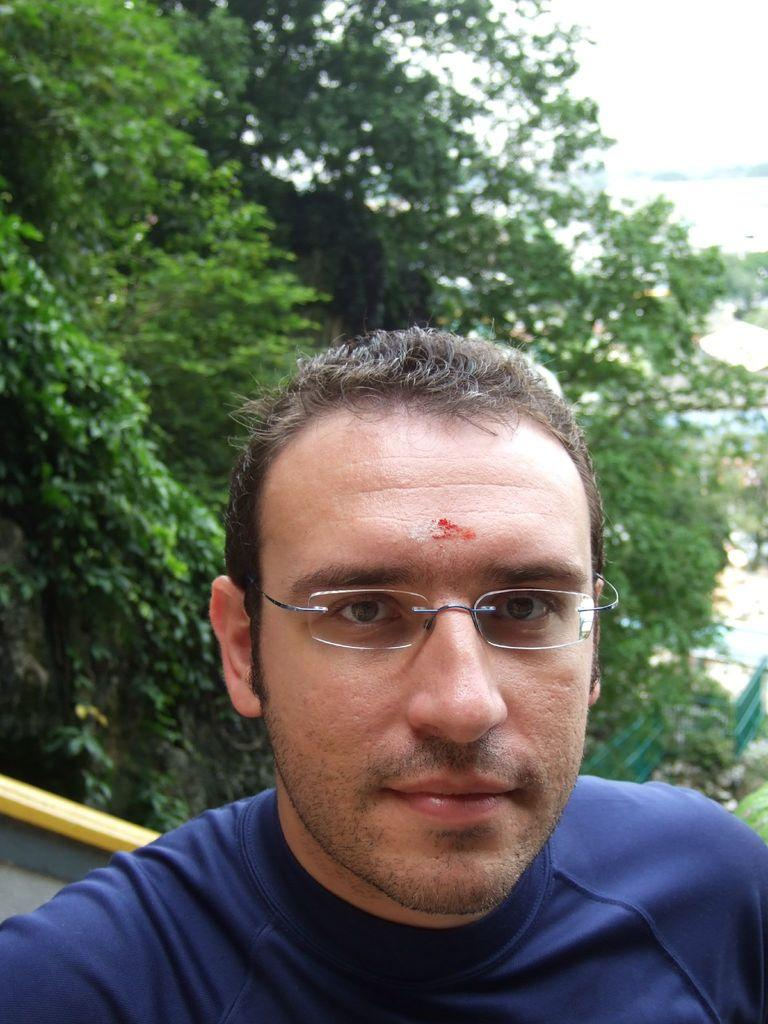Who is the main subject in the image? There is a man in the center of the image. What is the man wearing in the image? The man is wearing glasses. What can be seen in the background of the image? There are trees in the background of the image. What type of lace can be seen on the man's socks in the image? There is no mention of socks or lace in the image, so it cannot be determined if any lace is present. 